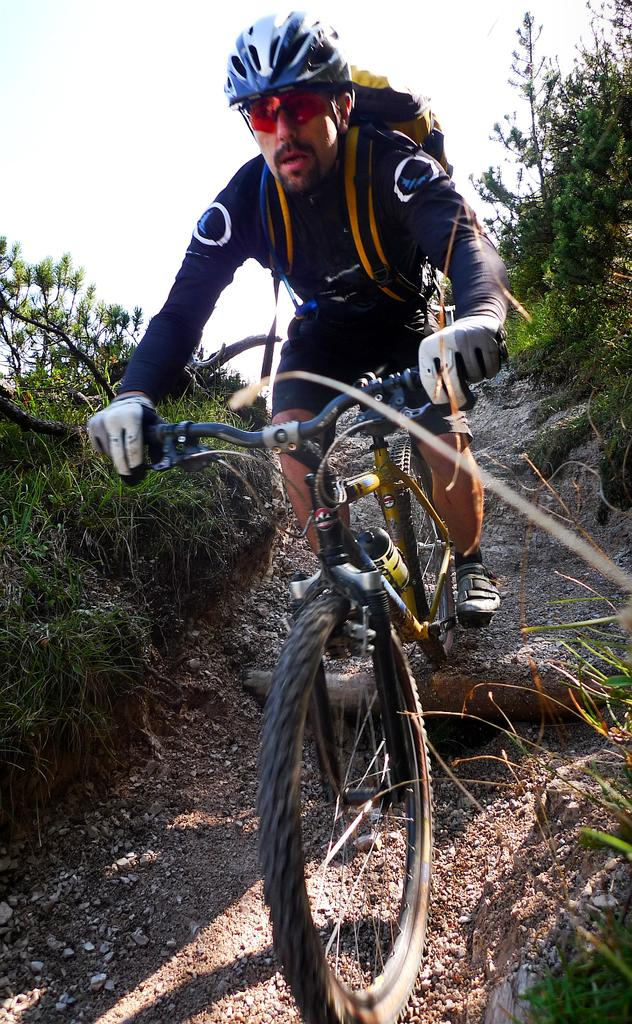What is the man in the image doing? The man is riding a bicycle in the image. What safety precaution is the man taking while riding the bicycle? The man is wearing a helmet. What else is the man wearing while riding the bicycle? The man is wearing spectacles. What is the man carrying while riding the bicycle? The man is carrying a bag. What can be seen in the background of the image? There are trees in the background of the image. What type of window can be seen in the image? There is no window present in the image; it features a man riding a bicycle. What is the downtown area like in the image? There is no downtown area present in the image; it features a man riding a bicycle in a setting with trees in the background. 